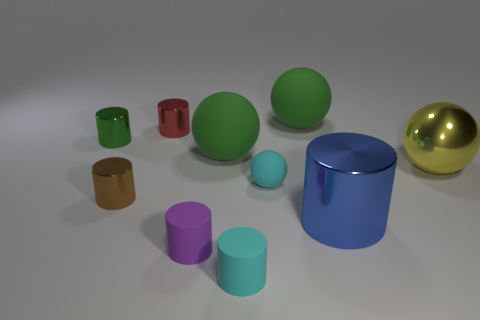What types of objects are depicted in the image, and what could their purpose be? The image shows a variety of simple geometric shapes like cylinders, spheres, and cubes. These objects, given their simplistic and varied nature, could serve as teaching aids for geometry, elements in a 3D modeling software test scene, or as part of a color study in visual arts. 